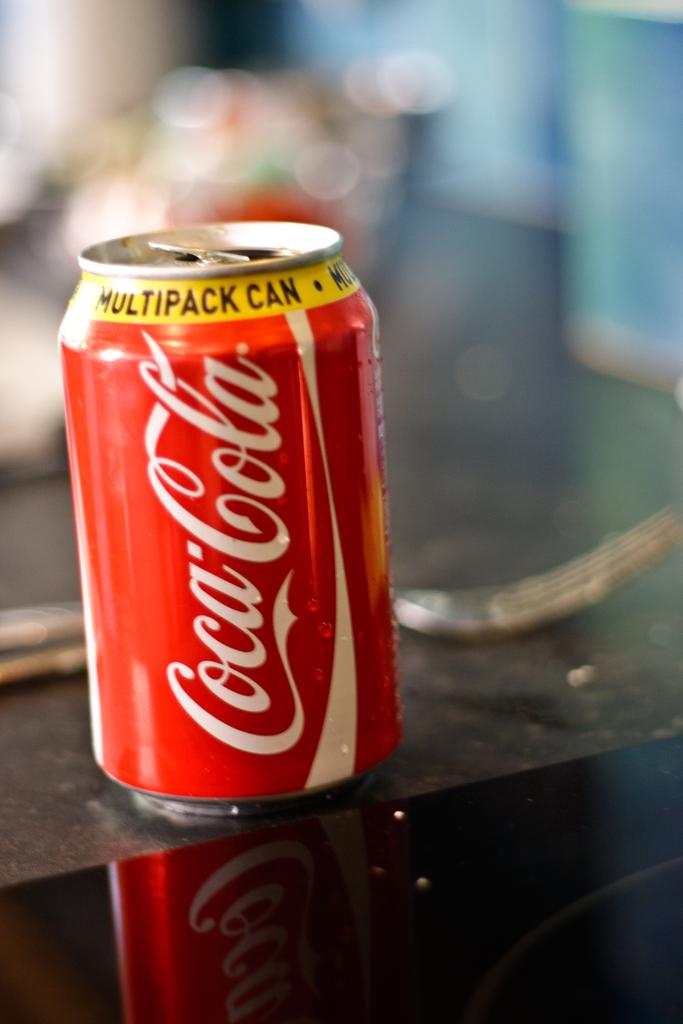<image>
Share a concise interpretation of the image provided. A Coca-Cola can has a yellow band at the top that says multipack. 